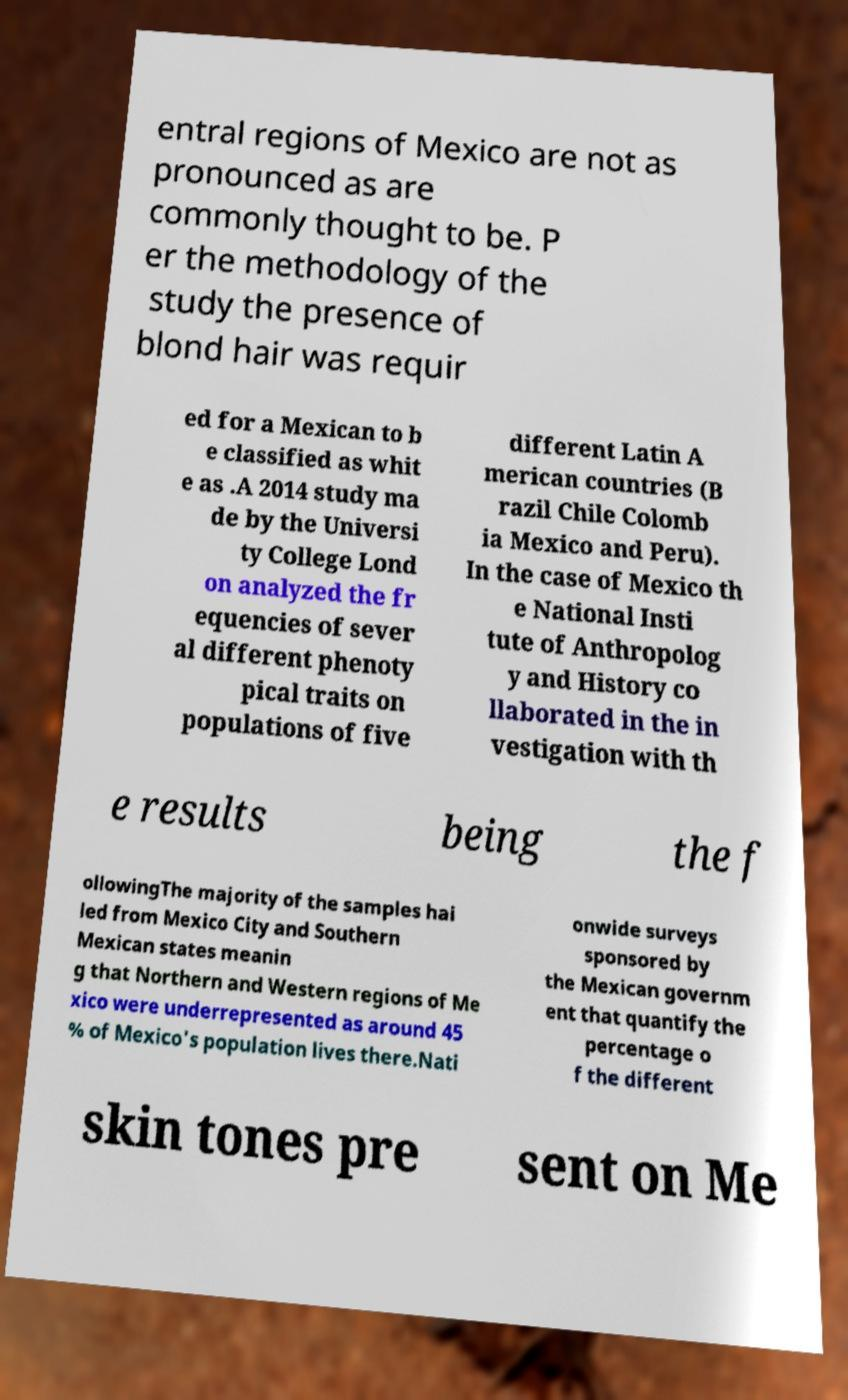Please identify and transcribe the text found in this image. entral regions of Mexico are not as pronounced as are commonly thought to be. P er the methodology of the study the presence of blond hair was requir ed for a Mexican to b e classified as whit e as .A 2014 study ma de by the Universi ty College Lond on analyzed the fr equencies of sever al different phenoty pical traits on populations of five different Latin A merican countries (B razil Chile Colomb ia Mexico and Peru). In the case of Mexico th e National Insti tute of Anthropolog y and History co llaborated in the in vestigation with th e results being the f ollowingThe majority of the samples hai led from Mexico City and Southern Mexican states meanin g that Northern and Western regions of Me xico were underrepresented as around 45 % of Mexico's population lives there.Nati onwide surveys sponsored by the Mexican governm ent that quantify the percentage o f the different skin tones pre sent on Me 